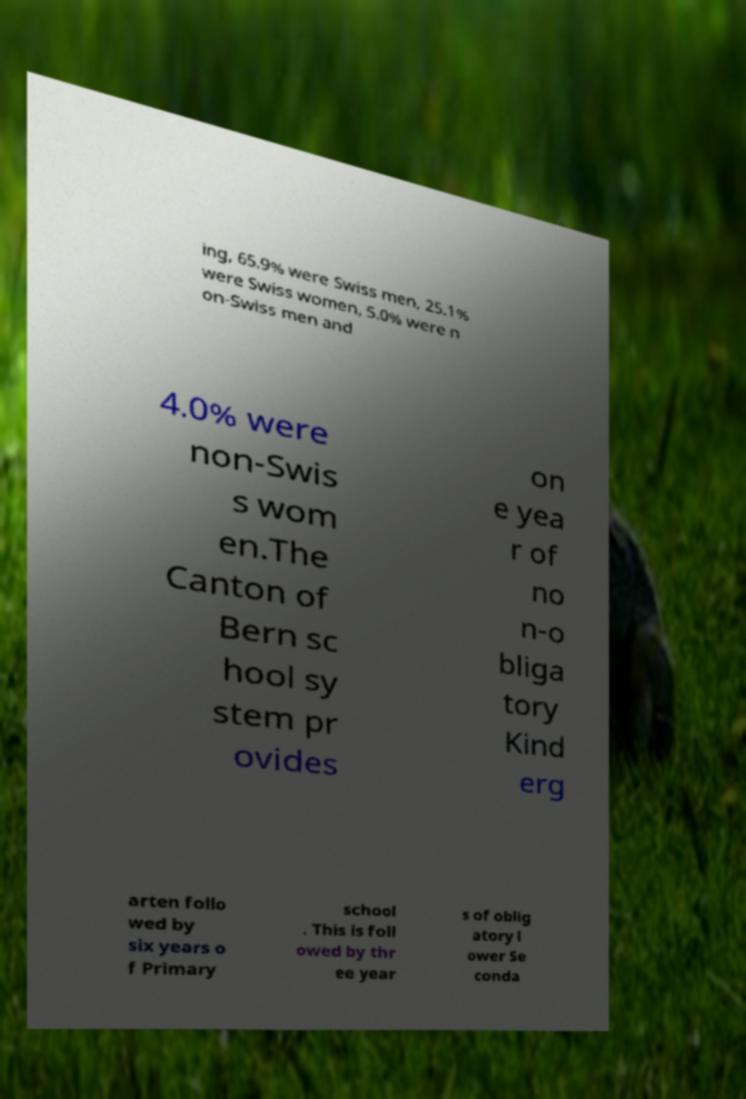Can you read and provide the text displayed in the image?This photo seems to have some interesting text. Can you extract and type it out for me? ing, 65.9% were Swiss men, 25.1% were Swiss women, 5.0% were n on-Swiss men and 4.0% were non-Swis s wom en.The Canton of Bern sc hool sy stem pr ovides on e yea r of no n-o bliga tory Kind erg arten follo wed by six years o f Primary school . This is foll owed by thr ee year s of oblig atory l ower Se conda 